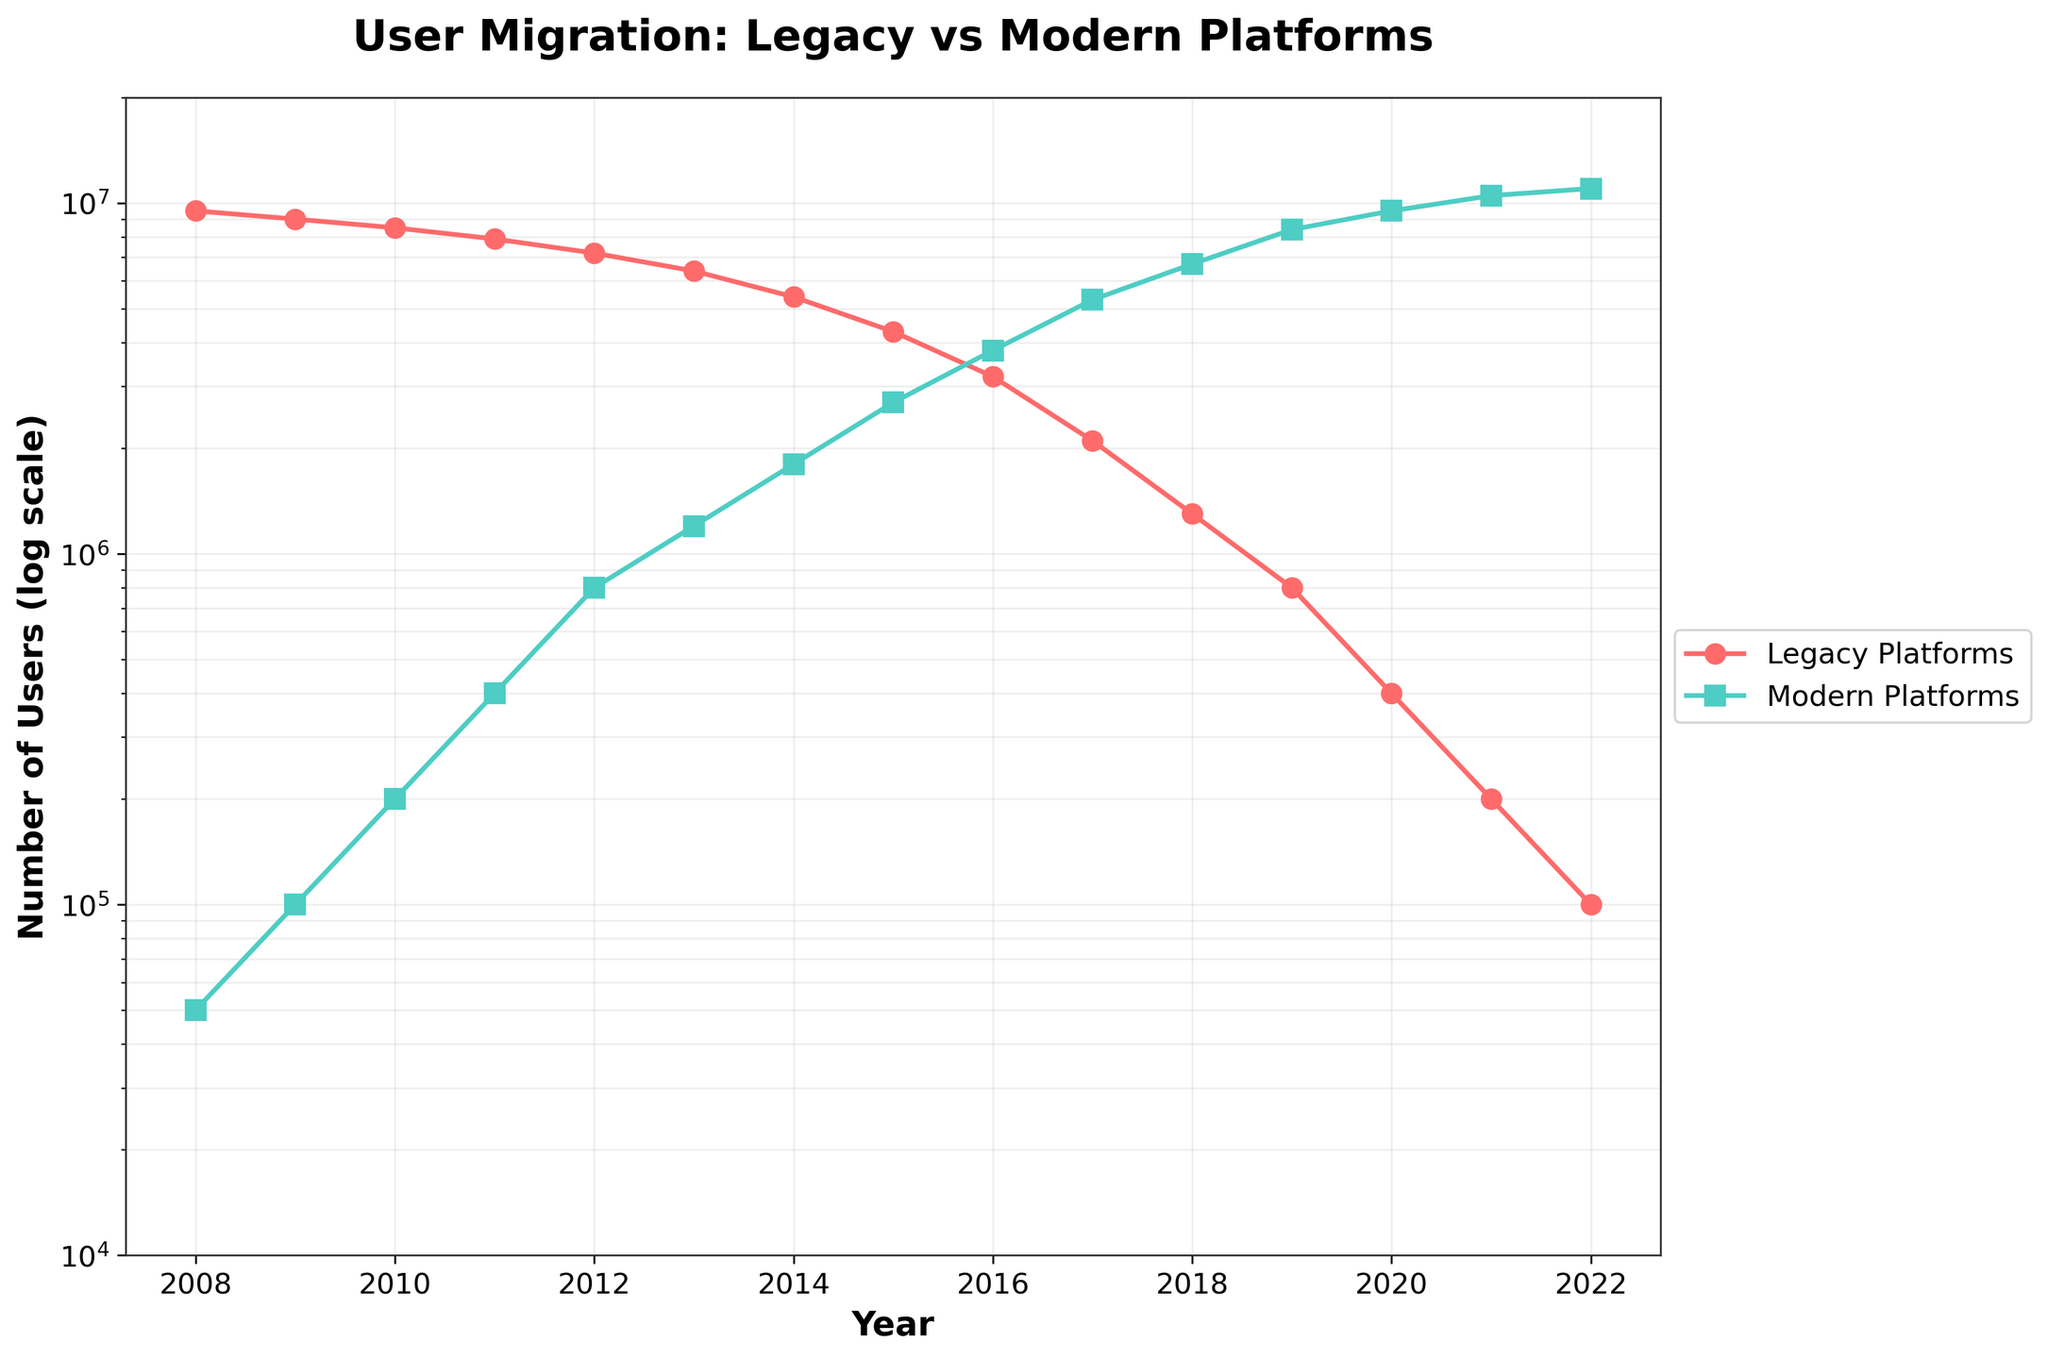what is the title of the figure? The title of the figure is generally located at the top of the chart. In this figure, it clearly states the subject of the graph.
Answer: User Migration: Legacy vs Modern Platforms what are the y-axis limits in the figure? The y-axis limits are defined by the range of the displayed values. In this figure, the lower limit is at 10,000 and the upper limit is at 20,000,000.
Answer: 10,000 to 20,000,000 around which year did users on modern platforms surpass those on legacy platforms? By observing the crossover point of the two lines representing legacy and modern platforms, the crossover occurs around the year 2016.
Answer: 2016 how many years did it take for users on modern platforms to exceed 10 million? Users on modern platforms reached 10 million by the years' end in 2021. The data starts in 2008. So, it took 2021 - 2008 = 13 years for the number to exceed 10 million.
Answer: 13 years what was the ratio of users on modern platforms to those on legacy platforms in 2020? In 2020, the number of users on modern platforms is 9,500,000, and on legacy platforms is 400,000. The ratio is 9,500,000 to 400,000, which simplifies to 95/4 or 23.75.
Answer: 23.75 by how much did the number of users on legacy platforms decrease from 2008 to 2022? In 2008, there were 9,500,000 users on legacy platforms and in 2022, there were 100,000 users. The decrease is 9,500,000 - 100,000 = 9,400,000.
Answer: 9,400,000 is the growth in users on modern platforms linear or exponential based on the log scale? An exponential growth on a linear scale would present as a straight line on a log scale. Observing the modern platforms' line, it appears straight, indicating exponential growth.
Answer: Exponential at which years did the number of legacy platform users drop below 1 million? The number of legacy platform users dropped below 1 million after the year 2019. Specifically, it reached 800,000 in 2019 and continued to decrease.
Answer: 2019 which year had the highest number of users on legacy platforms, and what is that number? By looking at the data points on the figure, the highest number of users on legacy platforms appears in 2008, with 9,500,000 users.
Answer: 2008, 9,500,000 what can you infer about user migration trends from this figure? The figure shows a steady decline in the number of users on legacy platforms and a rapid increase in users on modern platforms. This indicates a strong and consistent migration trend toward modern technologies.
Answer: Decline in legacy, increase in modern, strong migration trend 